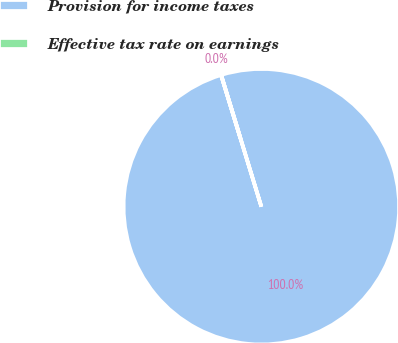<chart> <loc_0><loc_0><loc_500><loc_500><pie_chart><fcel>Provision for income taxes<fcel>Effective tax rate on earnings<nl><fcel>99.99%<fcel>0.01%<nl></chart> 